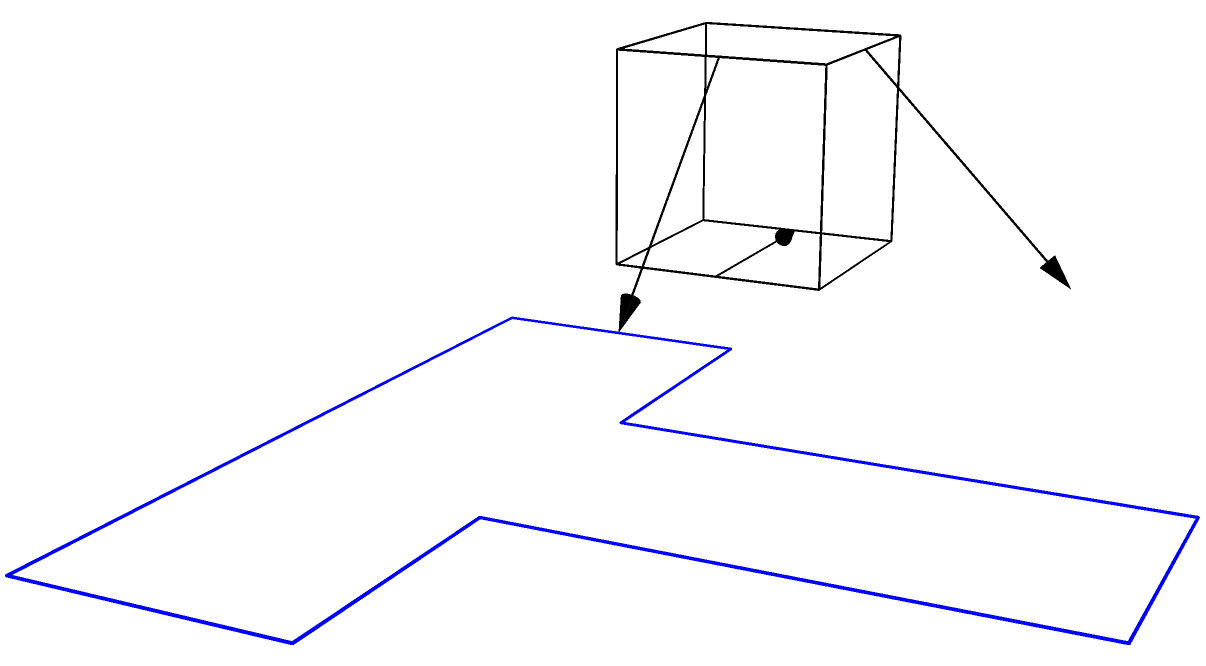In creating an interactive CSS animation to simulate the unfolding of a cube into a net, which CSS property would be most appropriate for smoothly transitioning the faces of the cube from their 3D positions to their 2D positions in the net? To create a smooth animation of a cube unfolding into a net using CSS, we need to consider the following steps:

1. Start with a 3D cube created using CSS transforms and perspective.

2. Each face of the cube needs to be positioned absolutely within a container.

3. The key to the unfolding animation is the transformation of each face from its 3D position to its 2D position in the net.

4. This transformation involves both rotation and translation for most faces.

5. The CSS `transform` property is ideal for this purpose as it can handle both 3D and 2D transformations smoothly.

6. We can use CSS transitions or keyframe animations to animate the `transform` property.

7. The `transform` property allows us to apply multiple transformations in a single declaration, which is perfect for complex movements like unfolding a cube.

8. For example, a side face might use a transform like:
   ```css
   transform: rotateY(90deg) translateZ(100px);
   ```
   to
   ```css
   transform: rotateY(0deg) translateX(200px);
   ```

9. The `transition` property or `@keyframes` can be used to animate these changes over time.

Given these considerations, the CSS `transform` property is the most appropriate for smoothly transitioning the faces of the cube from their 3D positions to their 2D positions in the net.
Answer: transform 